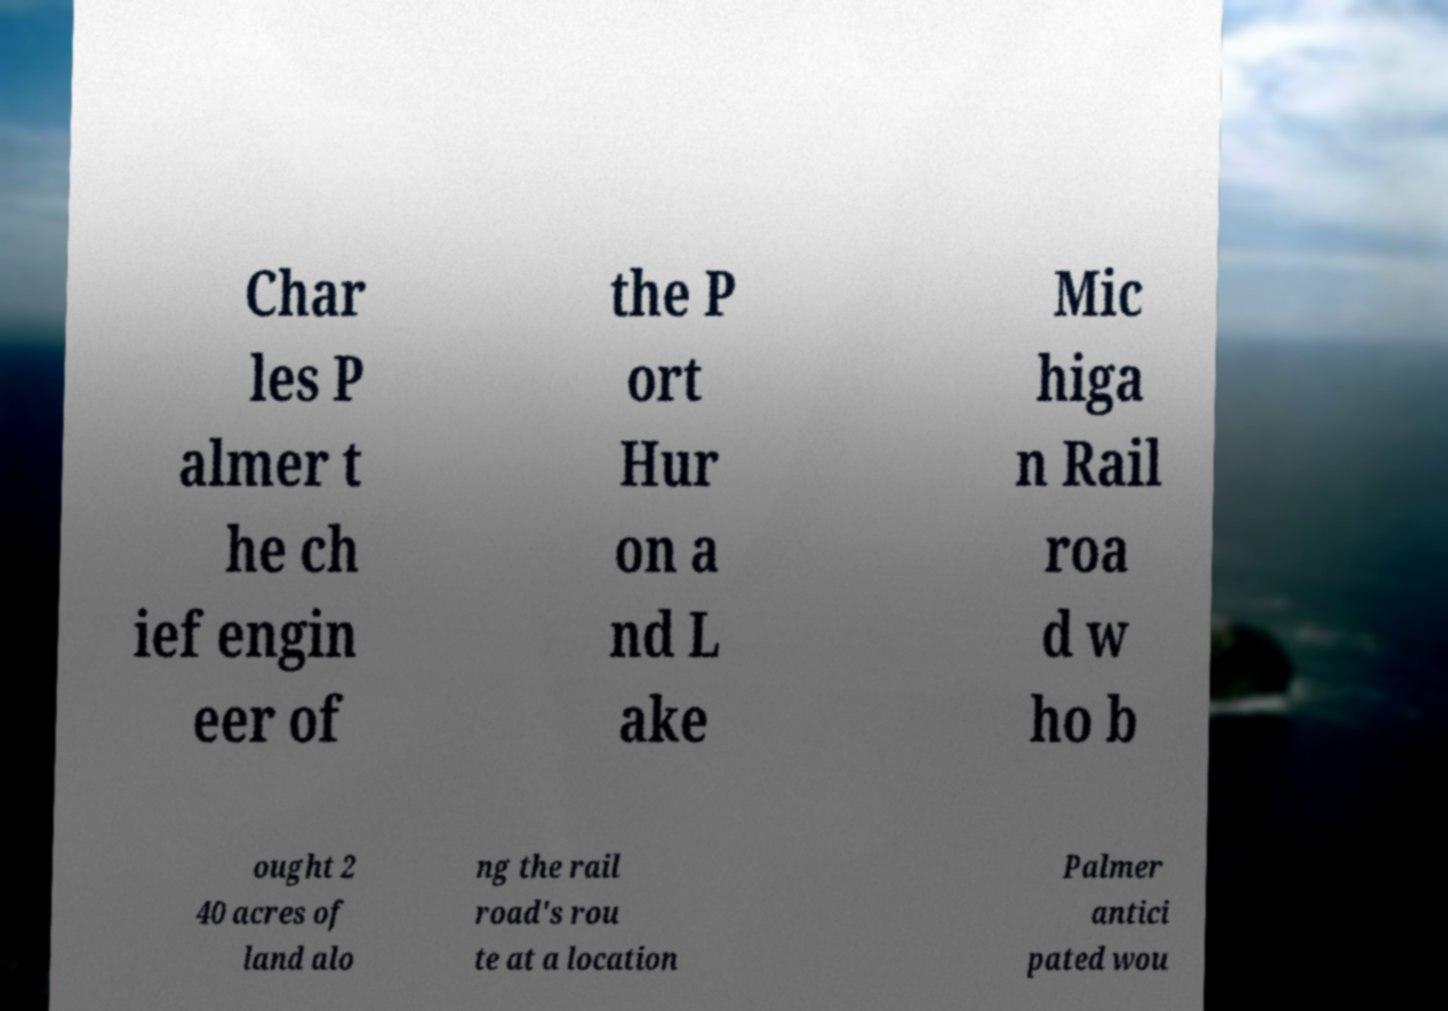Please identify and transcribe the text found in this image. Char les P almer t he ch ief engin eer of the P ort Hur on a nd L ake Mic higa n Rail roa d w ho b ought 2 40 acres of land alo ng the rail road's rou te at a location Palmer antici pated wou 